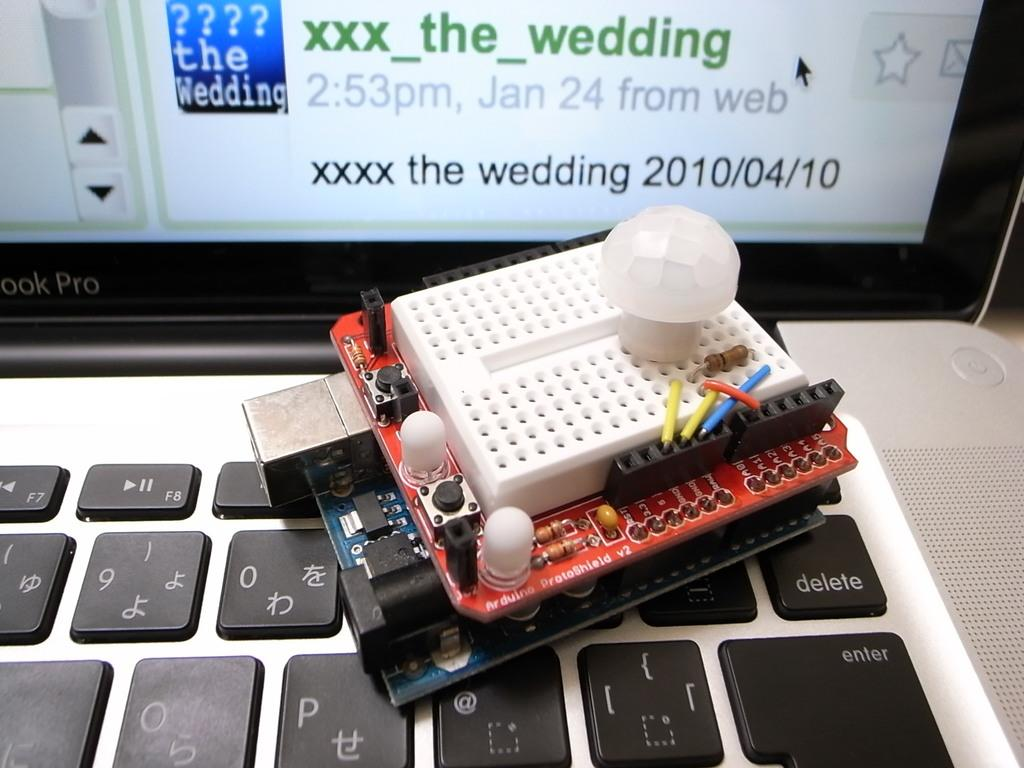<image>
Render a clear and concise summary of the photo. Piece of technology on top of a keyboard with a screen that says WEDDING on it. 